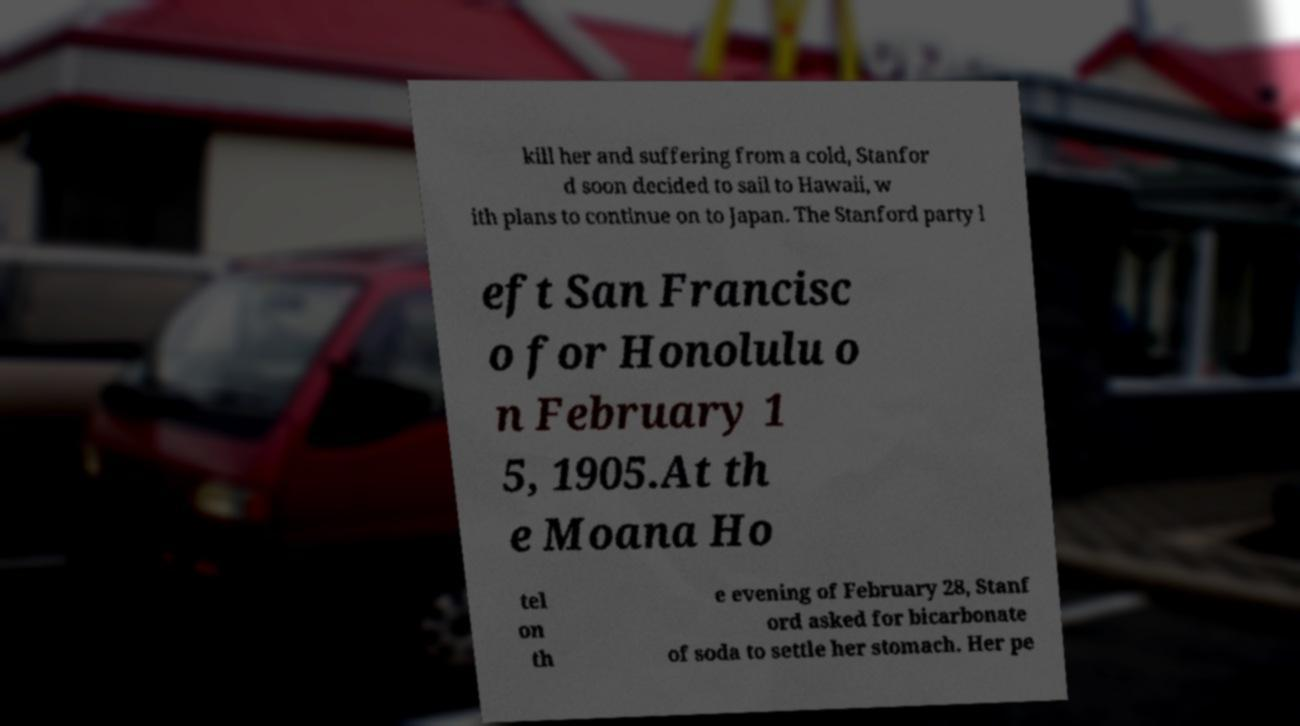Could you assist in decoding the text presented in this image and type it out clearly? kill her and suffering from a cold, Stanfor d soon decided to sail to Hawaii, w ith plans to continue on to Japan. The Stanford party l eft San Francisc o for Honolulu o n February 1 5, 1905.At th e Moana Ho tel on th e evening of February 28, Stanf ord asked for bicarbonate of soda to settle her stomach. Her pe 